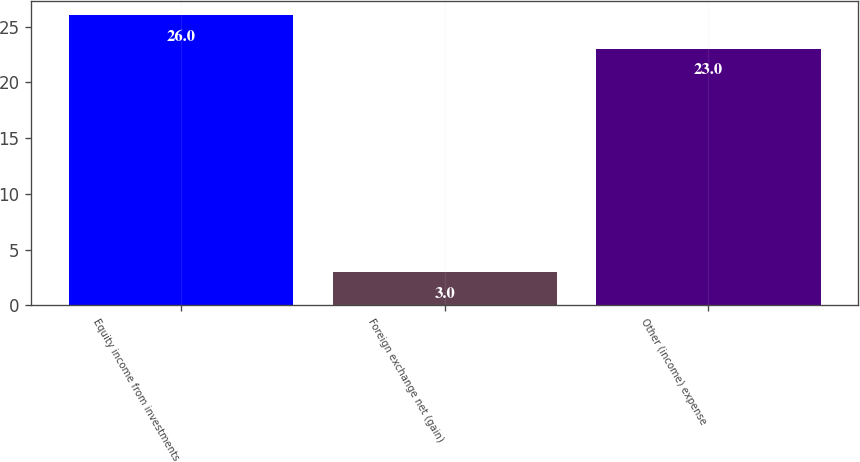Convert chart to OTSL. <chart><loc_0><loc_0><loc_500><loc_500><bar_chart><fcel>Equity income from investments<fcel>Foreign exchange net (gain)<fcel>Other (income) expense<nl><fcel>26<fcel>3<fcel>23<nl></chart> 